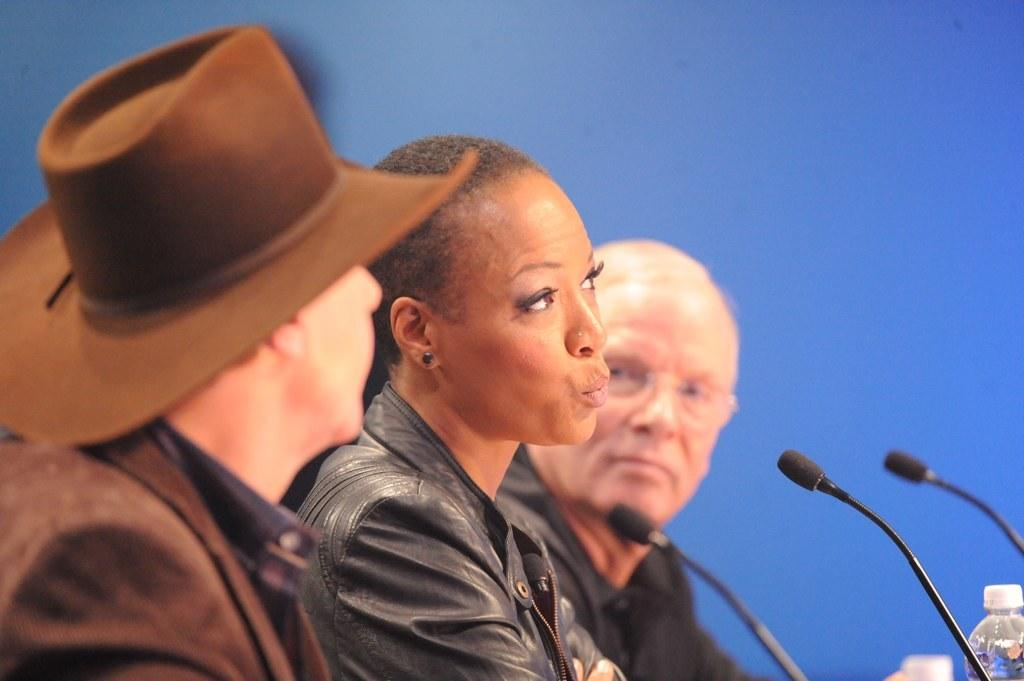What is happening in the foreground of the image? There are people sitting in the foreground of the image. What is located in front of the people? There are mice and bottles in front of the people. What color is the background of the image? The background of the image is blue. What type of metal can be seen in the image? There is no metal present in the image. Is there a church visible in the image? There is no church visible in the image. 